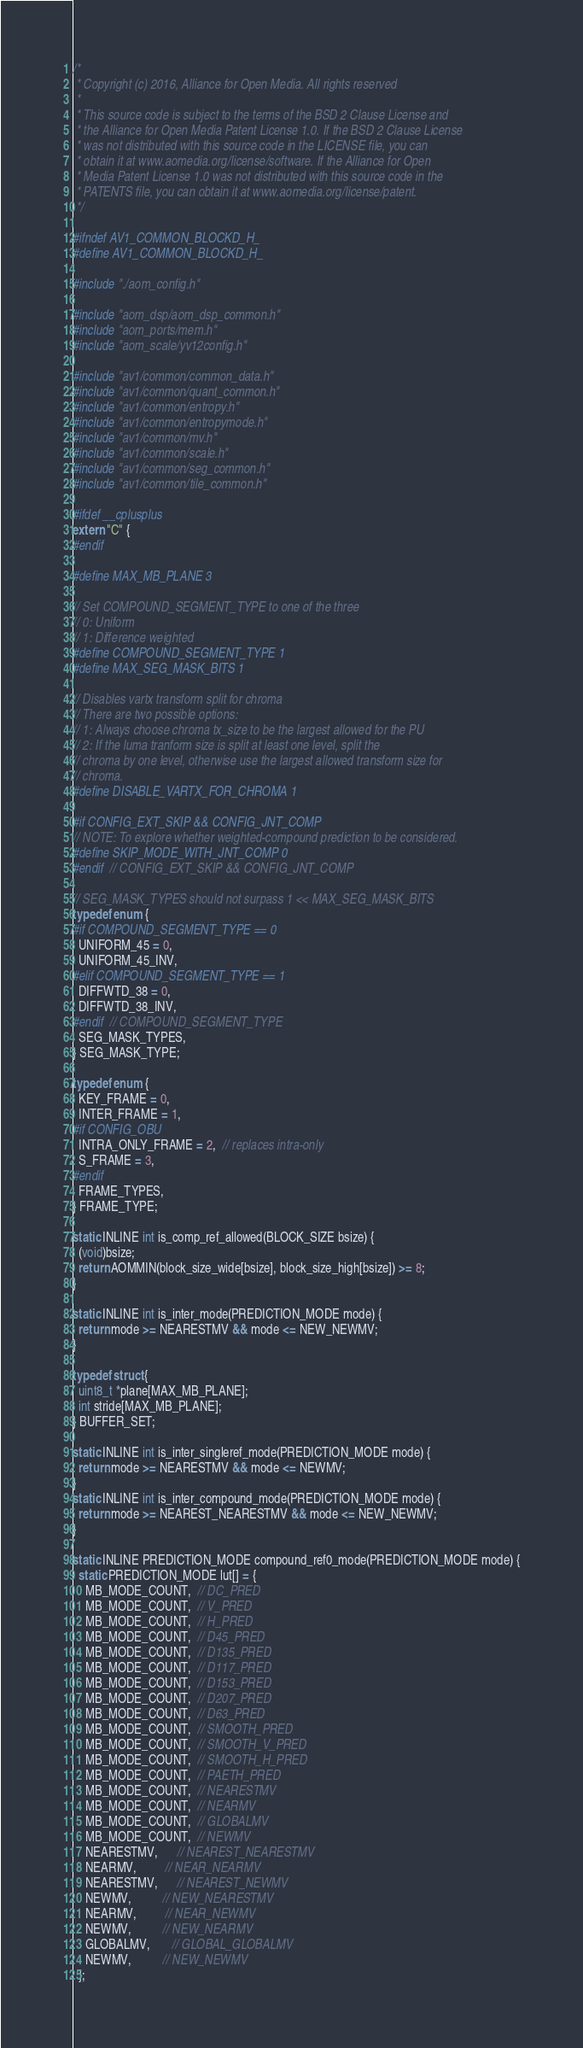<code> <loc_0><loc_0><loc_500><loc_500><_C_>/*
 * Copyright (c) 2016, Alliance for Open Media. All rights reserved
 *
 * This source code is subject to the terms of the BSD 2 Clause License and
 * the Alliance for Open Media Patent License 1.0. If the BSD 2 Clause License
 * was not distributed with this source code in the LICENSE file, you can
 * obtain it at www.aomedia.org/license/software. If the Alliance for Open
 * Media Patent License 1.0 was not distributed with this source code in the
 * PATENTS file, you can obtain it at www.aomedia.org/license/patent.
 */

#ifndef AV1_COMMON_BLOCKD_H_
#define AV1_COMMON_BLOCKD_H_

#include "./aom_config.h"

#include "aom_dsp/aom_dsp_common.h"
#include "aom_ports/mem.h"
#include "aom_scale/yv12config.h"

#include "av1/common/common_data.h"
#include "av1/common/quant_common.h"
#include "av1/common/entropy.h"
#include "av1/common/entropymode.h"
#include "av1/common/mv.h"
#include "av1/common/scale.h"
#include "av1/common/seg_common.h"
#include "av1/common/tile_common.h"

#ifdef __cplusplus
extern "C" {
#endif

#define MAX_MB_PLANE 3

// Set COMPOUND_SEGMENT_TYPE to one of the three
// 0: Uniform
// 1: Difference weighted
#define COMPOUND_SEGMENT_TYPE 1
#define MAX_SEG_MASK_BITS 1

// Disables vartx transform split for chroma
// There are two possible options:
// 1: Always choose chroma tx_size to be the largest allowed for the PU
// 2: If the luma tranform size is split at least one level, split the
// chroma by one level, otherwise use the largest allowed transform size for
// chroma.
#define DISABLE_VARTX_FOR_CHROMA 1

#if CONFIG_EXT_SKIP && CONFIG_JNT_COMP
// NOTE: To explore whether weighted-compound prediction to be considered.
#define SKIP_MODE_WITH_JNT_COMP 0
#endif  // CONFIG_EXT_SKIP && CONFIG_JNT_COMP

// SEG_MASK_TYPES should not surpass 1 << MAX_SEG_MASK_BITS
typedef enum {
#if COMPOUND_SEGMENT_TYPE == 0
  UNIFORM_45 = 0,
  UNIFORM_45_INV,
#elif COMPOUND_SEGMENT_TYPE == 1
  DIFFWTD_38 = 0,
  DIFFWTD_38_INV,
#endif  // COMPOUND_SEGMENT_TYPE
  SEG_MASK_TYPES,
} SEG_MASK_TYPE;

typedef enum {
  KEY_FRAME = 0,
  INTER_FRAME = 1,
#if CONFIG_OBU
  INTRA_ONLY_FRAME = 2,  // replaces intra-only
  S_FRAME = 3,
#endif
  FRAME_TYPES,
} FRAME_TYPE;

static INLINE int is_comp_ref_allowed(BLOCK_SIZE bsize) {
  (void)bsize;
  return AOMMIN(block_size_wide[bsize], block_size_high[bsize]) >= 8;
}

static INLINE int is_inter_mode(PREDICTION_MODE mode) {
  return mode >= NEARESTMV && mode <= NEW_NEWMV;
}

typedef struct {
  uint8_t *plane[MAX_MB_PLANE];
  int stride[MAX_MB_PLANE];
} BUFFER_SET;

static INLINE int is_inter_singleref_mode(PREDICTION_MODE mode) {
  return mode >= NEARESTMV && mode <= NEWMV;
}
static INLINE int is_inter_compound_mode(PREDICTION_MODE mode) {
  return mode >= NEAREST_NEARESTMV && mode <= NEW_NEWMV;
}

static INLINE PREDICTION_MODE compound_ref0_mode(PREDICTION_MODE mode) {
  static PREDICTION_MODE lut[] = {
    MB_MODE_COUNT,  // DC_PRED
    MB_MODE_COUNT,  // V_PRED
    MB_MODE_COUNT,  // H_PRED
    MB_MODE_COUNT,  // D45_PRED
    MB_MODE_COUNT,  // D135_PRED
    MB_MODE_COUNT,  // D117_PRED
    MB_MODE_COUNT,  // D153_PRED
    MB_MODE_COUNT,  // D207_PRED
    MB_MODE_COUNT,  // D63_PRED
    MB_MODE_COUNT,  // SMOOTH_PRED
    MB_MODE_COUNT,  // SMOOTH_V_PRED
    MB_MODE_COUNT,  // SMOOTH_H_PRED
    MB_MODE_COUNT,  // PAETH_PRED
    MB_MODE_COUNT,  // NEARESTMV
    MB_MODE_COUNT,  // NEARMV
    MB_MODE_COUNT,  // GLOBALMV
    MB_MODE_COUNT,  // NEWMV
    NEARESTMV,      // NEAREST_NEARESTMV
    NEARMV,         // NEAR_NEARMV
    NEARESTMV,      // NEAREST_NEWMV
    NEWMV,          // NEW_NEARESTMV
    NEARMV,         // NEAR_NEWMV
    NEWMV,          // NEW_NEARMV
    GLOBALMV,       // GLOBAL_GLOBALMV
    NEWMV,          // NEW_NEWMV
  };</code> 